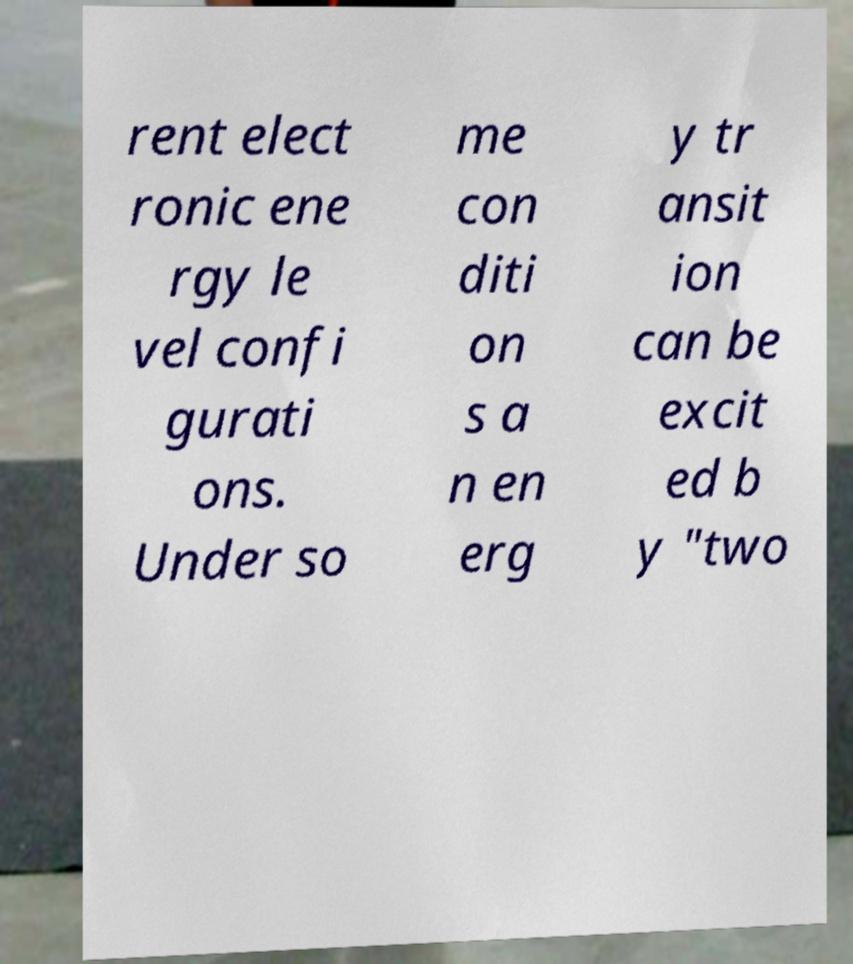For documentation purposes, I need the text within this image transcribed. Could you provide that? rent elect ronic ene rgy le vel confi gurati ons. Under so me con diti on s a n en erg y tr ansit ion can be excit ed b y "two 